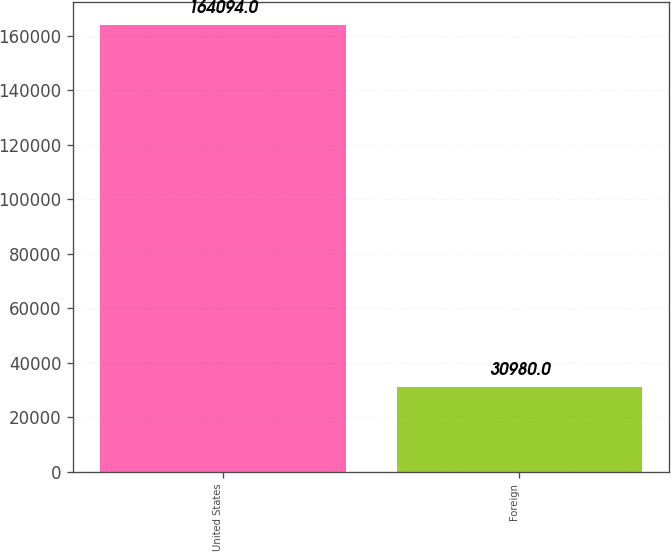Convert chart to OTSL. <chart><loc_0><loc_0><loc_500><loc_500><bar_chart><fcel>United States<fcel>Foreign<nl><fcel>164094<fcel>30980<nl></chart> 